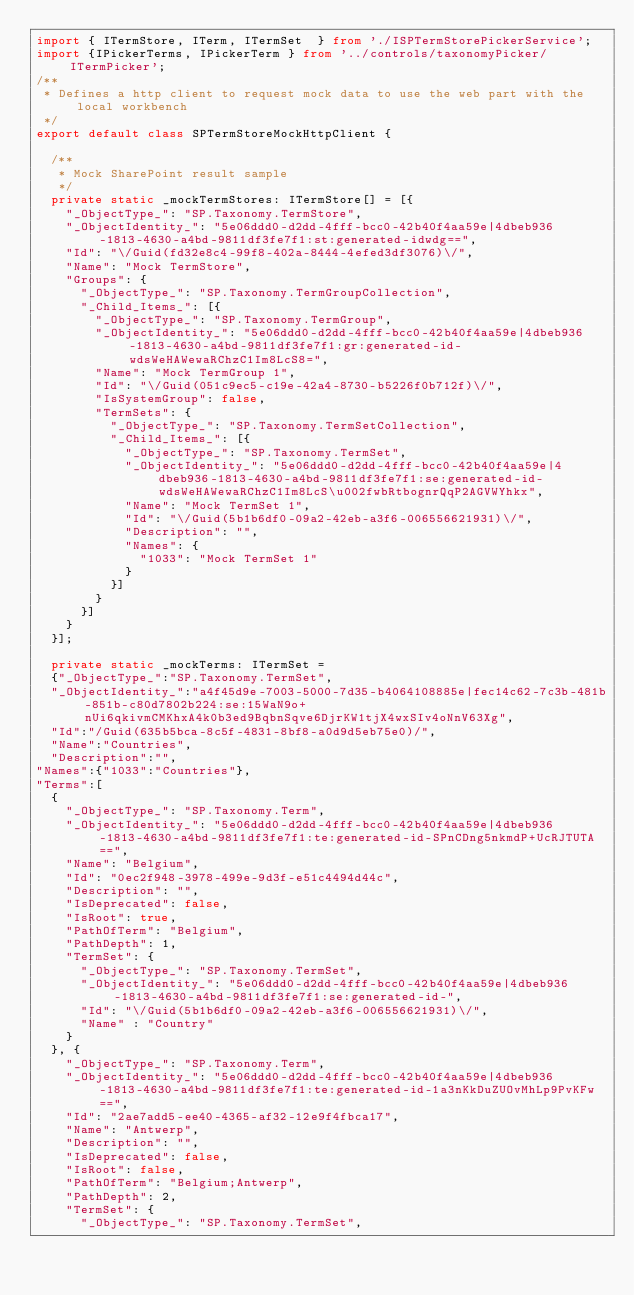<code> <loc_0><loc_0><loc_500><loc_500><_TypeScript_>import { ITermStore, ITerm, ITermSet  } from './ISPTermStorePickerService';
import {IPickerTerms, IPickerTerm } from '../controls/taxonomyPicker/ITermPicker';
/**
 * Defines a http client to request mock data to use the web part with the local workbench
 */
export default class SPTermStoreMockHttpClient {

  /**
   * Mock SharePoint result sample
   */
  private static _mockTermStores: ITermStore[] = [{
    "_ObjectType_": "SP.Taxonomy.TermStore",
    "_ObjectIdentity_": "5e06ddd0-d2dd-4fff-bcc0-42b40f4aa59e|4dbeb936-1813-4630-a4bd-9811df3fe7f1:st:generated-idwdg==",
    "Id": "\/Guid(fd32e8c4-99f8-402a-8444-4efed3df3076)\/",
    "Name": "Mock TermStore",
    "Groups": {
      "_ObjectType_": "SP.Taxonomy.TermGroupCollection",
      "_Child_Items_": [{
        "_ObjectType_": "SP.Taxonomy.TermGroup",
        "_ObjectIdentity_": "5e06ddd0-d2dd-4fff-bcc0-42b40f4aa59e|4dbeb936-1813-4630-a4bd-9811df3fe7f1:gr:generated-id-wdsWeHAWewaRChzC1Im8LcS8=",
        "Name": "Mock TermGroup 1",
        "Id": "\/Guid(051c9ec5-c19e-42a4-8730-b5226f0b712f)\/",
        "IsSystemGroup": false,
        "TermSets": {
          "_ObjectType_": "SP.Taxonomy.TermSetCollection",
          "_Child_Items_": [{
            "_ObjectType_": "SP.Taxonomy.TermSet",
            "_ObjectIdentity_": "5e06ddd0-d2dd-4fff-bcc0-42b40f4aa59e|4dbeb936-1813-4630-a4bd-9811df3fe7f1:se:generated-id-wdsWeHAWewaRChzC1Im8LcS\u002fwbRtbognrQqP2AGVWYhkx",
            "Name": "Mock TermSet 1",
            "Id": "\/Guid(5b1b6df0-09a2-42eb-a3f6-006556621931)\/",
            "Description": "",
            "Names": {
              "1033": "Mock TermSet 1"
            }
          }]
        }
      }]
    }
  }];

  private static _mockTerms: ITermSet = 
  {"_ObjectType_":"SP.Taxonomy.TermSet",
  "_ObjectIdentity_":"a4f45d9e-7003-5000-7d35-b4064108885e|fec14c62-7c3b-481b-851b-c80d7802b224:se:15WaN9o+nUi6qkivmCMKhxA4k0b3ed9BqbnSqve6DjrKW1tjX4wxSIv4oNnV63Xg",
  "Id":"/Guid(635b5bca-8c5f-4831-8bf8-a0d9d5eb75e0)/",
  "Name":"Countries",
  "Description":"",
"Names":{"1033":"Countries"},
"Terms":[
  {
    "_ObjectType_": "SP.Taxonomy.Term",
    "_ObjectIdentity_": "5e06ddd0-d2dd-4fff-bcc0-42b40f4aa59e|4dbeb936-1813-4630-a4bd-9811df3fe7f1:te:generated-id-SPnCDng5nkmdP+UcRJTUTA==",
    "Name": "Belgium",
    "Id": "0ec2f948-3978-499e-9d3f-e51c4494d44c",
    "Description": "",
    "IsDeprecated": false,
    "IsRoot": true,
    "PathOfTerm": "Belgium",
    "PathDepth": 1,
    "TermSet": {
      "_ObjectType_": "SP.Taxonomy.TermSet",
      "_ObjectIdentity_": "5e06ddd0-d2dd-4fff-bcc0-42b40f4aa59e|4dbeb936-1813-4630-a4bd-9811df3fe7f1:se:generated-id-",
      "Id": "\/Guid(5b1b6df0-09a2-42eb-a3f6-006556621931)\/",
      "Name" : "Country"
    }
  }, {
    "_ObjectType_": "SP.Taxonomy.Term",
    "_ObjectIdentity_": "5e06ddd0-d2dd-4fff-bcc0-42b40f4aa59e|4dbeb936-1813-4630-a4bd-9811df3fe7f1:te:generated-id-1a3nKkDuZUOvMhLp9PvKFw==",
    "Id": "2ae7add5-ee40-4365-af32-12e9f4fbca17",
    "Name": "Antwerp",
    "Description": "",
    "IsDeprecated": false,
    "IsRoot": false,
    "PathOfTerm": "Belgium;Antwerp",
    "PathDepth": 2,
    "TermSet": {
      "_ObjectType_": "SP.Taxonomy.TermSet",</code> 